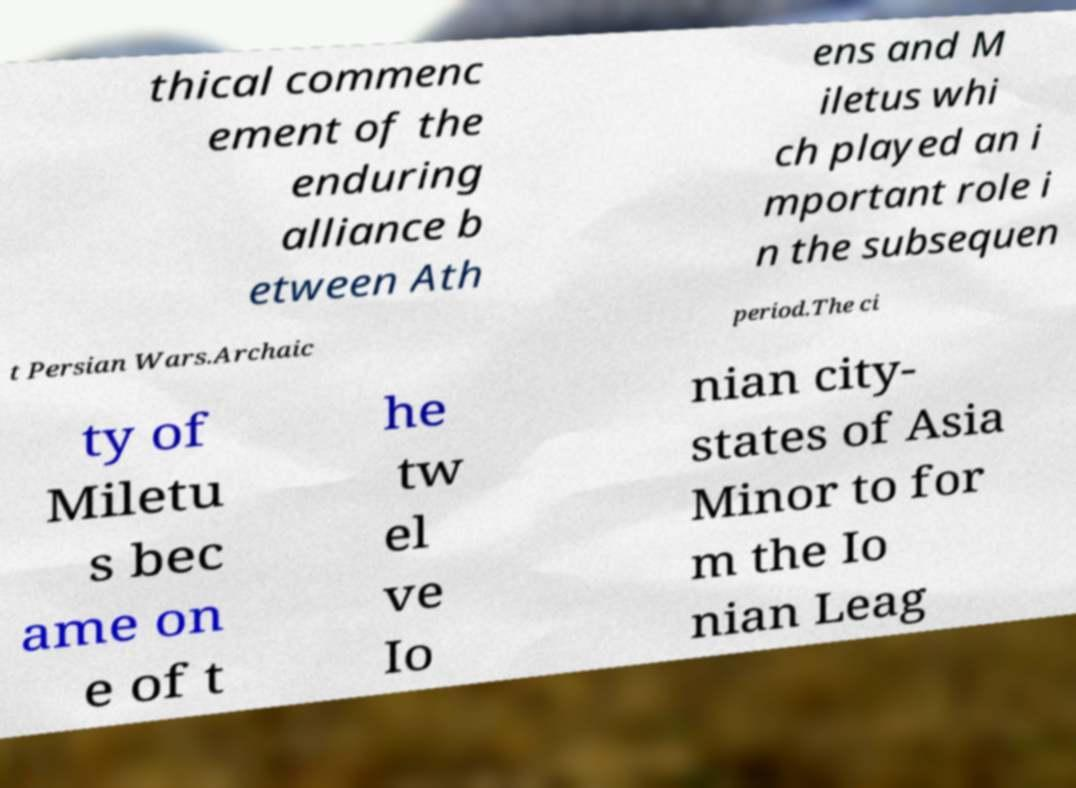Please read and relay the text visible in this image. What does it say? thical commenc ement of the enduring alliance b etween Ath ens and M iletus whi ch played an i mportant role i n the subsequen t Persian Wars.Archaic period.The ci ty of Miletu s bec ame on e of t he tw el ve Io nian city- states of Asia Minor to for m the Io nian Leag 